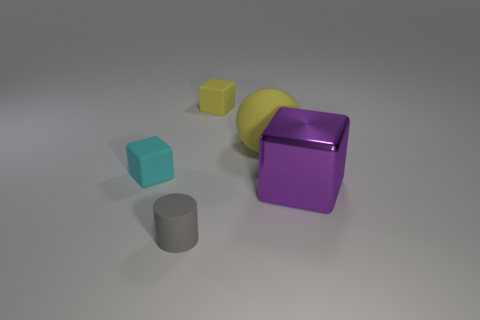How many other objects are there of the same size as the yellow ball?
Ensure brevity in your answer.  1. What number of objects are cubes behind the large yellow object or rubber objects in front of the tiny yellow matte cube?
Provide a short and direct response. 4. Does the small gray cylinder have the same material as the small cube that is in front of the tiny yellow object?
Give a very brief answer. Yes. How many other things are there of the same shape as the tiny yellow rubber thing?
Provide a succinct answer. 2. There is a block that is on the right side of the small yellow rubber block that is on the right side of the matte thing in front of the cyan matte object; what is its material?
Offer a terse response. Metal. Are there an equal number of small cyan rubber objects that are on the right side of the cyan rubber thing and big purple metal cylinders?
Your answer should be very brief. Yes. Are the small thing in front of the tiny cyan thing and the block that is in front of the cyan thing made of the same material?
Provide a short and direct response. No. Are there any other things that have the same material as the big block?
Your response must be concise. No. There is a tiny object in front of the cyan matte block; is its shape the same as the yellow thing that is in front of the small yellow matte block?
Provide a short and direct response. No. Is the number of rubber spheres that are to the left of the cyan matte object less than the number of large gray metal blocks?
Keep it short and to the point. No. 